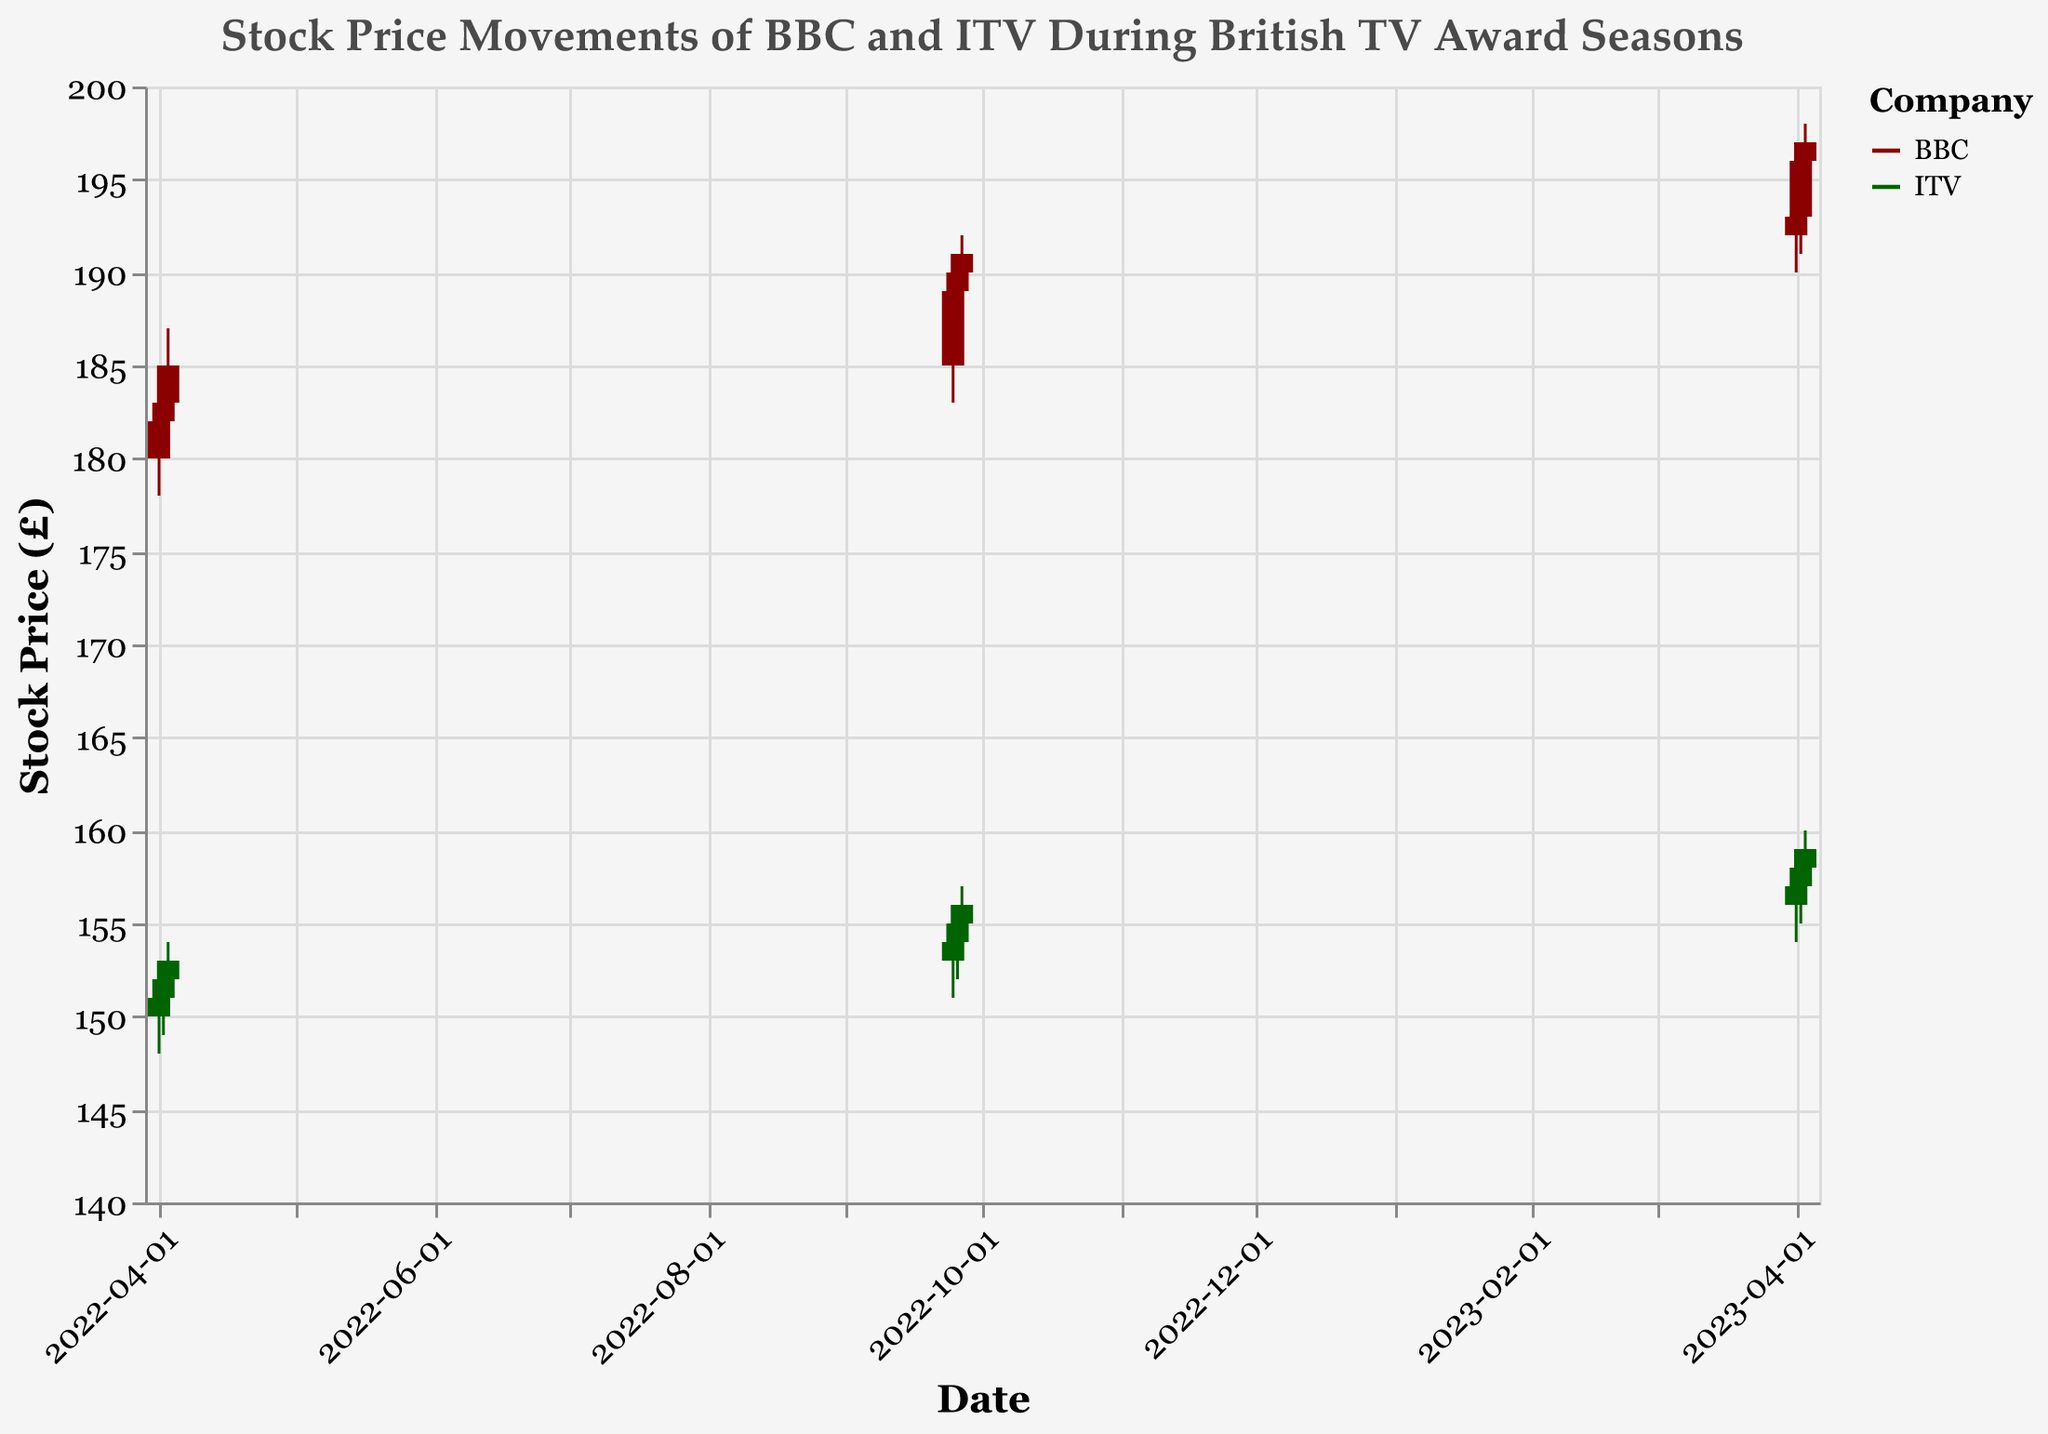What is the title of the figure? The title can be seen at the top of the figure. It is labeled as "Stock Price Movements of BBC and ITV During British TV Award Seasons".
Answer: Stock Price Movements of BBC and ITV During British TV Award Seasons Which company had a higher closing price on 2022-04-03? Compare the closing prices of BBC (185) and ITV (153) on 2022-04-03. BBC has a higher closing price.
Answer: BBC What is the maximum stock price for ITV during the period shown? The highest price ITV stock reached is given in the maximum 'High' field for ITV. It is 160, observed on 2023-04-03.
Answer: 160 Between 2022-09-25 and 2022-09-27, did BBC's closing price increase or decrease? BBC's closing prices for the given dates are 189, 190, and 191 respectively. Calculating the changes between consecutive days, the price increased overall.
Answer: Increased Which company had the highest trading volume on 2022-09-25? Compare the trading volumes of BBC (160,000) and ITV (140,000) on the specified date. BBC had the highest trading volume.
Answer: BBC Over which date range did BBC's stock price show a consistent daily increase in April 2023? BBC's stock prices from 2023-04-01 to 2023-04-03 are 193, 196, and 197 respectively, indicating a consistent daily increase over these dates.
Answer: 2023-04-01 to 2023-04-03 What is the difference between BBC’s highest and lowest stock price on 2022-09-27? The highest price BBC reached on 2022-09-27 is 192, and the lowest is 188. The difference is 192 - 188 = 4.
Answer: 4 Which company's stock price had a larger increase from its opening to its closing price on 2022-04-02? BBC's opening and closing prices on 2022-04-02 are 182 and 183 respectively, resulting in an increase of 1. ITV's prices are 151 and 152 respectively, also resulting in an increase of 1. Thus, neither company had a larger increase.
Answer: Neither What was the closing price trend for ITV from 2023-04-01 to 2023-04-03? ITV's closing prices for the given dates are 157, 158, and 159 respectively. The overall trend is an increase.
Answer: Increasing Between 2022-04-01 and 2022-04-03, which company saw the greater increase in stock price? BBC’s stock price increased from 182 to 185 (3) while ITV’s stock price increased from 151 to 153 (2). BBC saw the greater increase.
Answer: BBC 